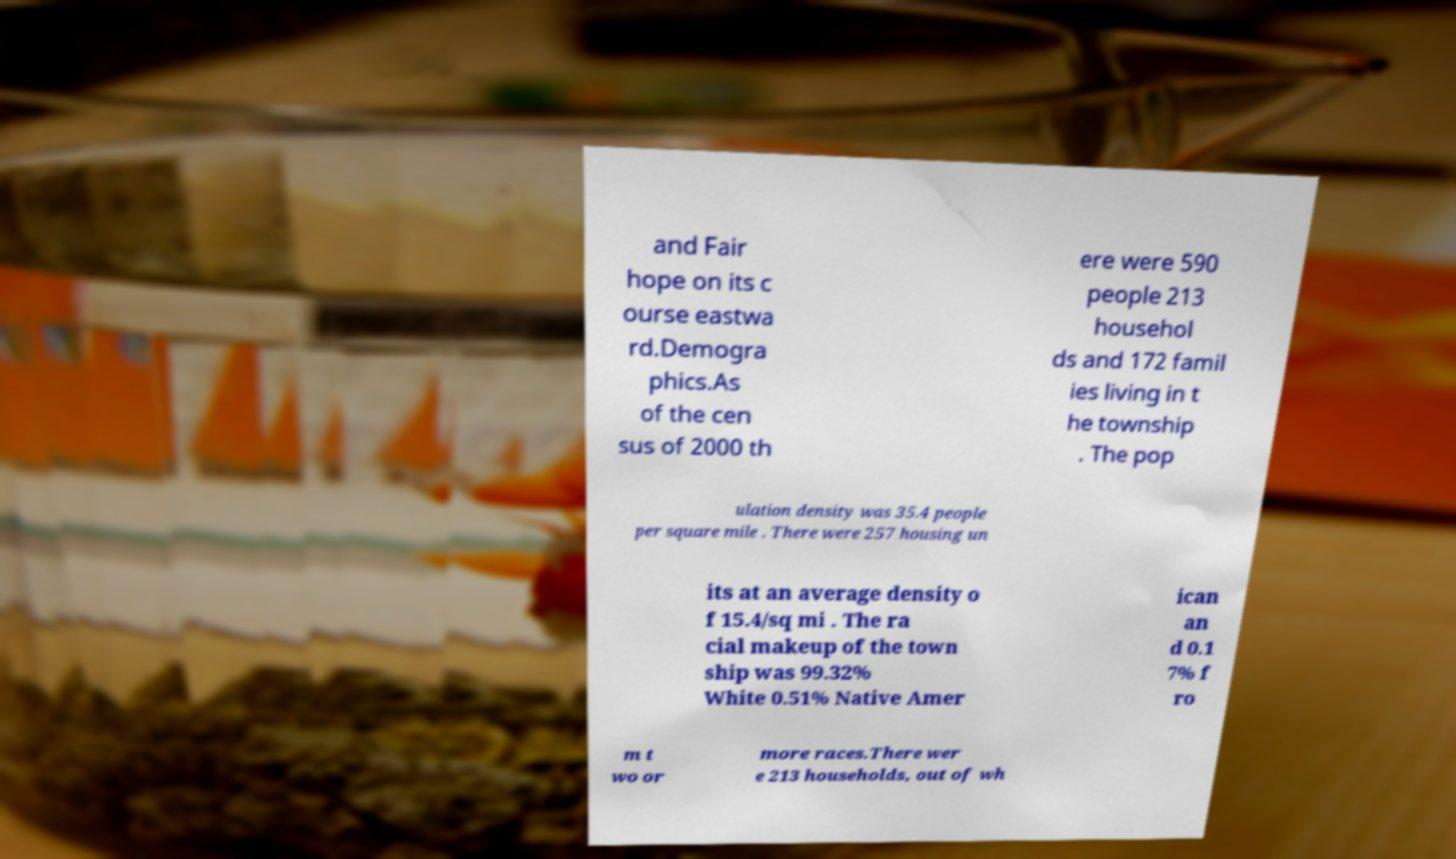For documentation purposes, I need the text within this image transcribed. Could you provide that? and Fair hope on its c ourse eastwa rd.Demogra phics.As of the cen sus of 2000 th ere were 590 people 213 househol ds and 172 famil ies living in t he township . The pop ulation density was 35.4 people per square mile . There were 257 housing un its at an average density o f 15.4/sq mi . The ra cial makeup of the town ship was 99.32% White 0.51% Native Amer ican an d 0.1 7% f ro m t wo or more races.There wer e 213 households, out of wh 